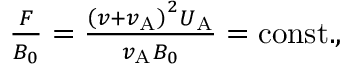Convert formula to latex. <formula><loc_0><loc_0><loc_500><loc_500>\begin{array} { r } { \frac { F } { B _ { 0 } } = \frac { \left ( v + v _ { A } \right ) ^ { 2 } U _ { A } } { v _ { A } B _ { 0 } } = c o n s t . , } \end{array}</formula> 